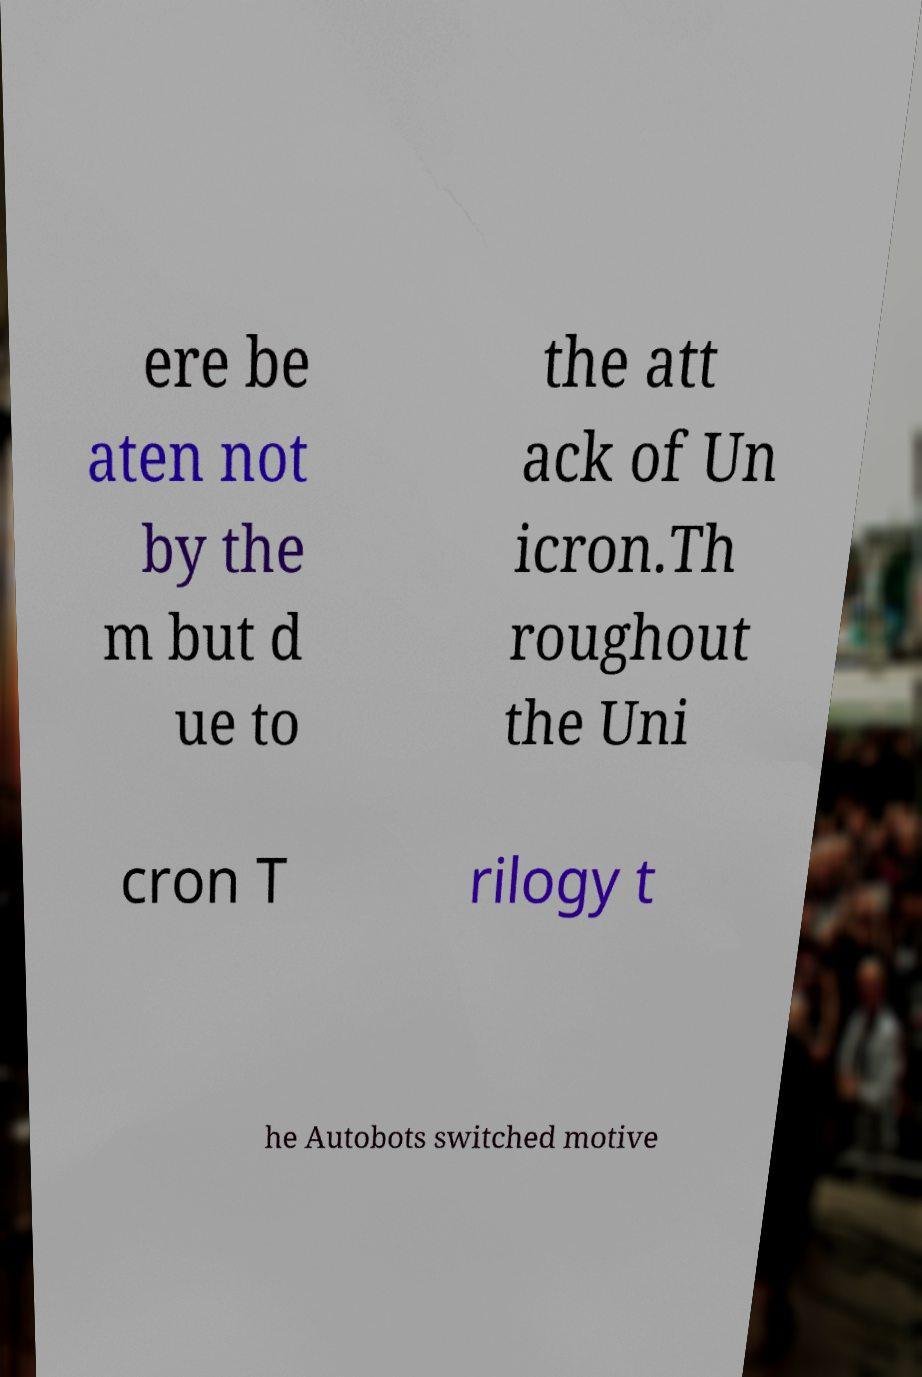For documentation purposes, I need the text within this image transcribed. Could you provide that? ere be aten not by the m but d ue to the att ack of Un icron.Th roughout the Uni cron T rilogy t he Autobots switched motive 